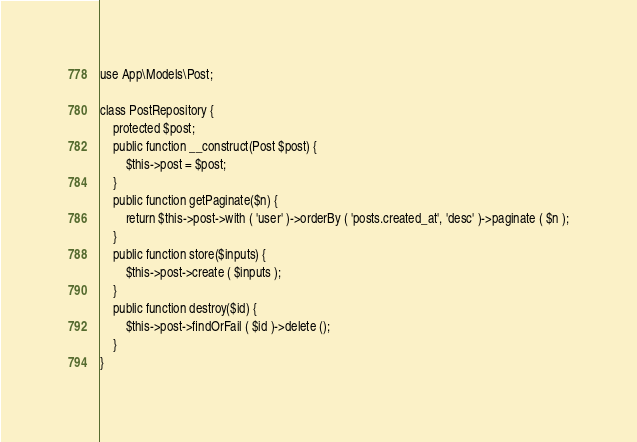Convert code to text. <code><loc_0><loc_0><loc_500><loc_500><_PHP_>use App\Models\Post;

class PostRepository {
	protected $post;
	public function __construct(Post $post) {
		$this->post = $post;
	}
	public function getPaginate($n) {
		return $this->post->with ( 'user' )->orderBy ( 'posts.created_at', 'desc' )->paginate ( $n );
	}
	public function store($inputs) {
		$this->post->create ( $inputs );
	}
	public function destroy($id) {
		$this->post->findOrFail ( $id )->delete ();
	}
}</code> 